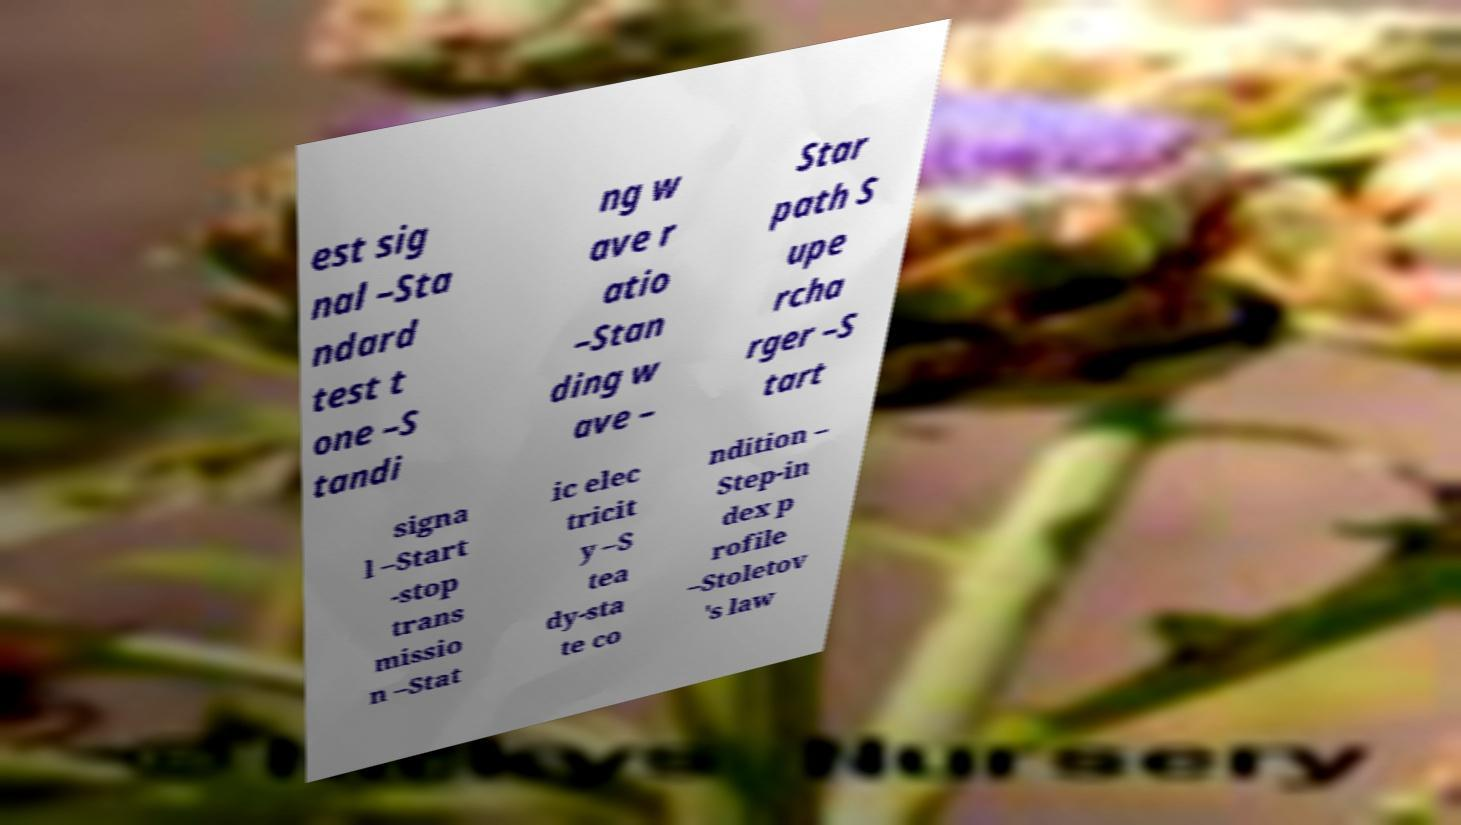I need the written content from this picture converted into text. Can you do that? est sig nal –Sta ndard test t one –S tandi ng w ave r atio –Stan ding w ave – Star path S upe rcha rger –S tart signa l –Start -stop trans missio n –Stat ic elec tricit y –S tea dy-sta te co ndition – Step-in dex p rofile –Stoletov 's law 